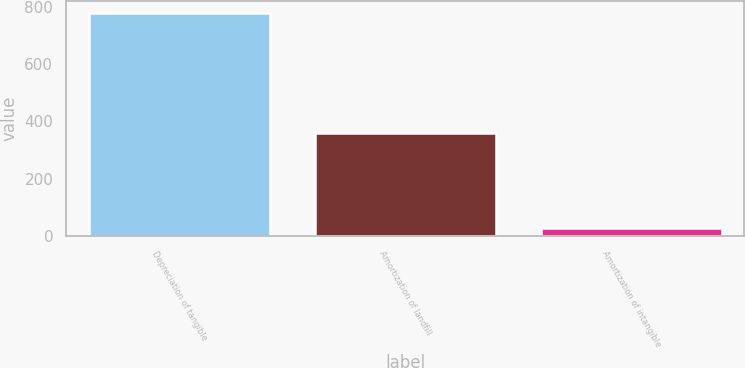Convert chart. <chart><loc_0><loc_0><loc_500><loc_500><bar_chart><fcel>Depreciation of tangible<fcel>Amortization of landfill<fcel>Amortization of intangible<nl><fcel>779<fcel>358<fcel>29<nl></chart> 